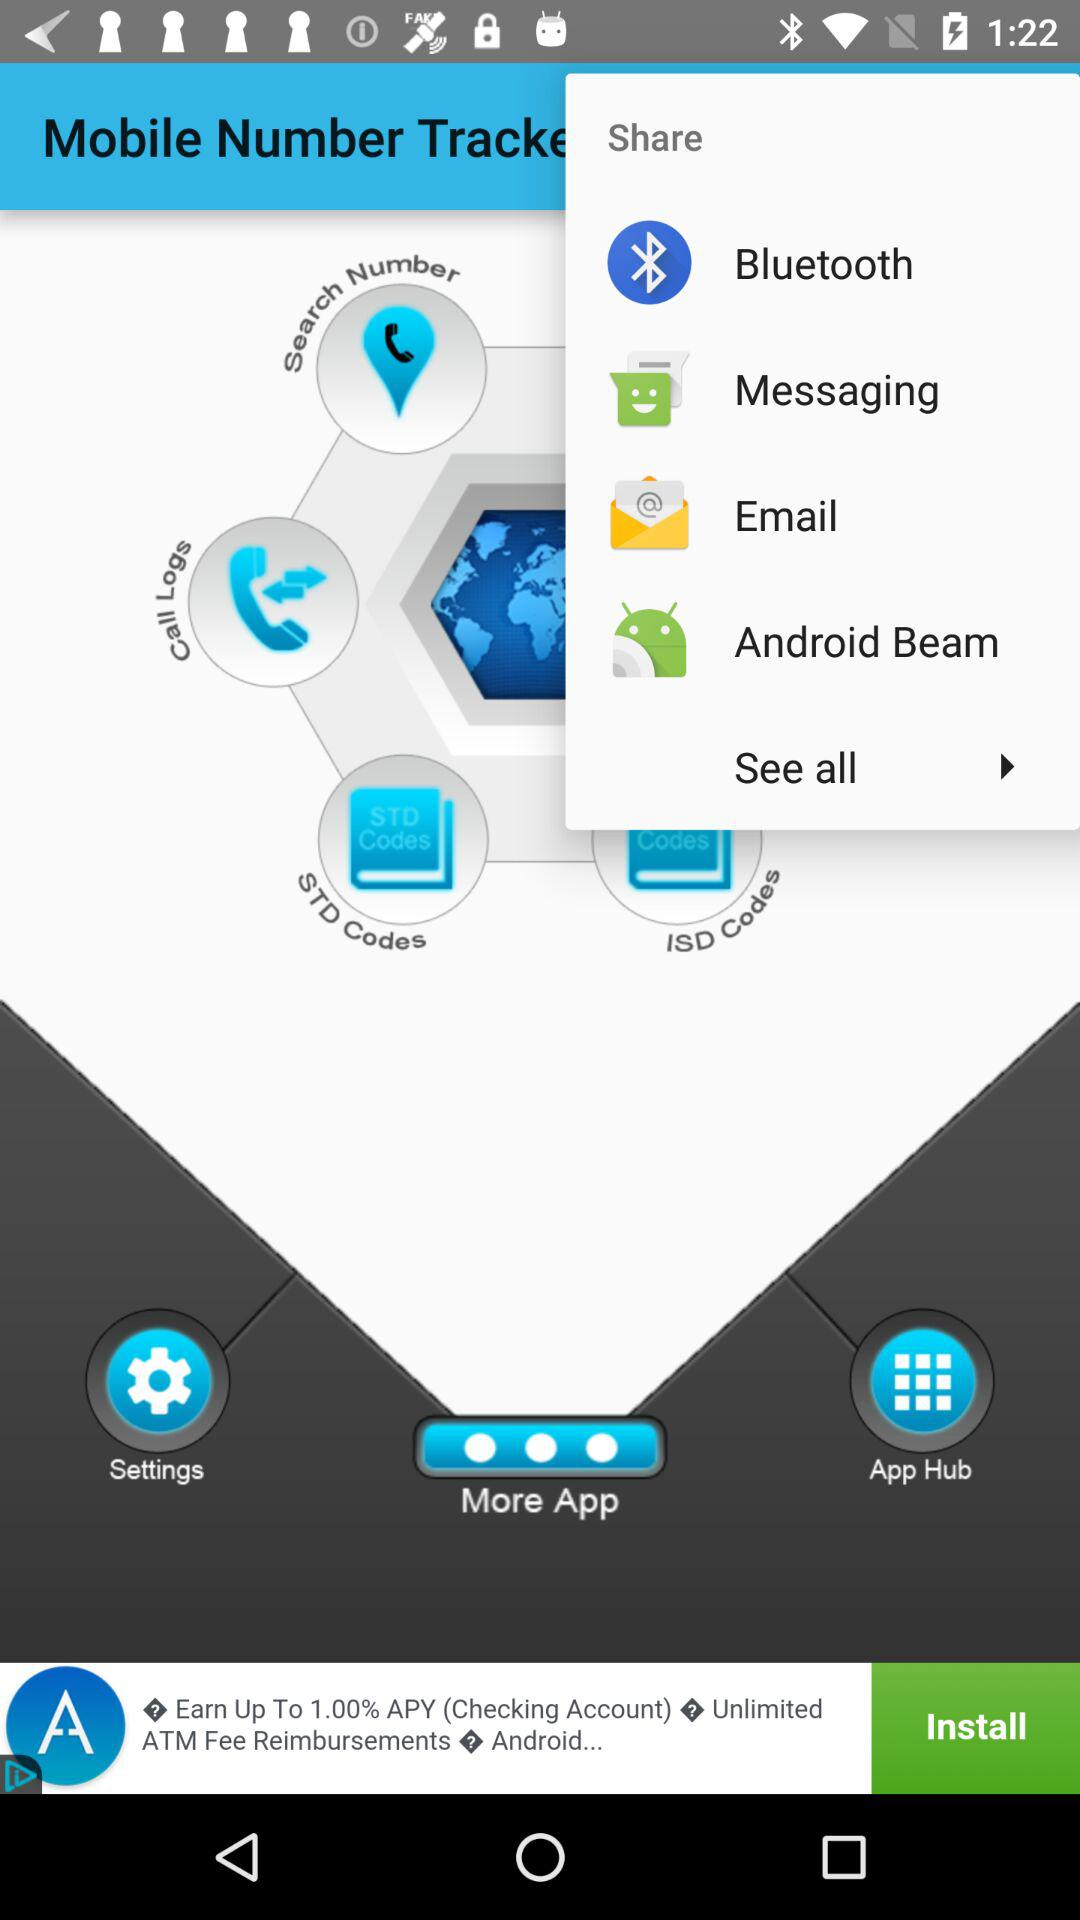What is the name of the application? The name of the application is "Mobile Number Tracker". 